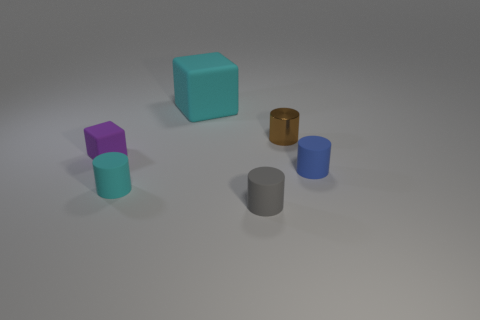Subtract all cyan matte cylinders. How many cylinders are left? 3 Subtract all cylinders. How many objects are left? 2 Add 2 tiny brown matte spheres. How many objects exist? 8 Subtract all brown cylinders. How many cylinders are left? 3 Subtract 1 cubes. How many cubes are left? 1 Subtract all cyan cubes. Subtract all cyan cylinders. How many cubes are left? 1 Subtract all brown cylinders. How many cyan blocks are left? 1 Subtract all cylinders. Subtract all big cyan matte objects. How many objects are left? 1 Add 3 large cyan cubes. How many large cyan cubes are left? 4 Add 5 blue cylinders. How many blue cylinders exist? 6 